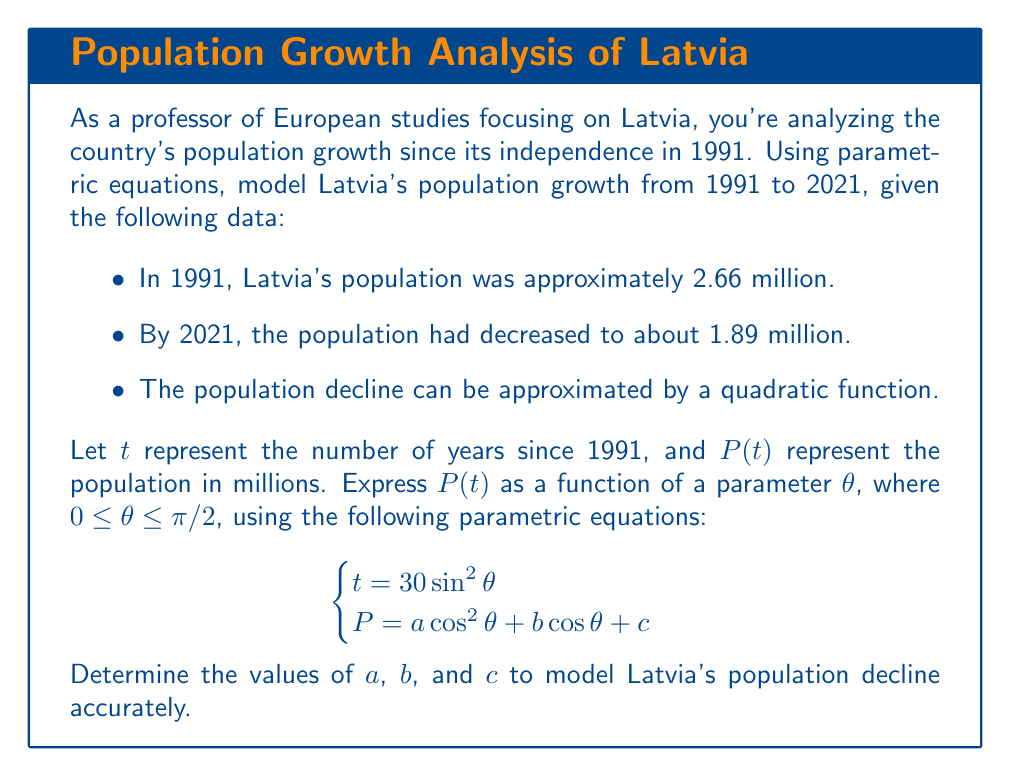Give your solution to this math problem. To solve this problem, we'll follow these steps:

1) We know two points on our curve:
   At $t=0$ (1991), $P=2.66$
   At $t=30$ (2021), $P=1.89$

2) We can use these points to set up two equations:
   When $\theta = 0$: $2.66 = a + b + c$
   When $\theta = \pi/2$: $1.89 = c$

3) We need a third equation to solve for $a$, $b$, and $c$. We can use the fact that the population decline is quadratic. In a quadratic function, the coefficient of the squared term determines the concavity. Let's assume the population reaches its minimum at $t=30$ (2021). This means:

   $\frac{dP}{dt} = 0$ when $t=30$

4) To find $\frac{dP}{dt}$, we use the chain rule:

   $\frac{dP}{dt} = \frac{dP}{d\theta} \cdot \frac{d\theta}{dt}$

5) From the given equations:
   $\frac{dt}{d\theta} = 60\sin\theta\cos\theta$
   $\frac{dP}{d\theta} = -2a\cos\theta\sin\theta - b\sin\theta$

6) Therefore:
   $\frac{dP}{dt} = \frac{-2a\cos\theta\sin\theta - b\sin\theta}{60\sin\theta\cos\theta} = -\frac{2a\cos\theta + b}{60\cos\theta}$

7) Setting this to 0 when $t=30$ (i.e., when $\theta=\pi/2$):
   $-\frac{2a\cos(\pi/2) + b}{60\cos(\pi/2)} = 0$
   This simplifies to: $b = 0$

8) Now we have three equations:
   $2.66 = a + c$
   $1.89 = c$
   $b = 0$

9) Solving this system:
   $c = 1.89$
   $a = 2.66 - 1.89 = 0.77$
   $b = 0$

Therefore, the parametric equations modeling Latvia's population decline are:

$$\begin{cases}
t = 30 \sin^2\theta \\
P = 0.77\cos^2\theta + 1.89
\end{cases}$$
Where $0 \leq \theta \leq \pi/2$ and $t$ represents years since 1991.
Answer: $a=0.77$, $b=0$, $c=1.89$ 